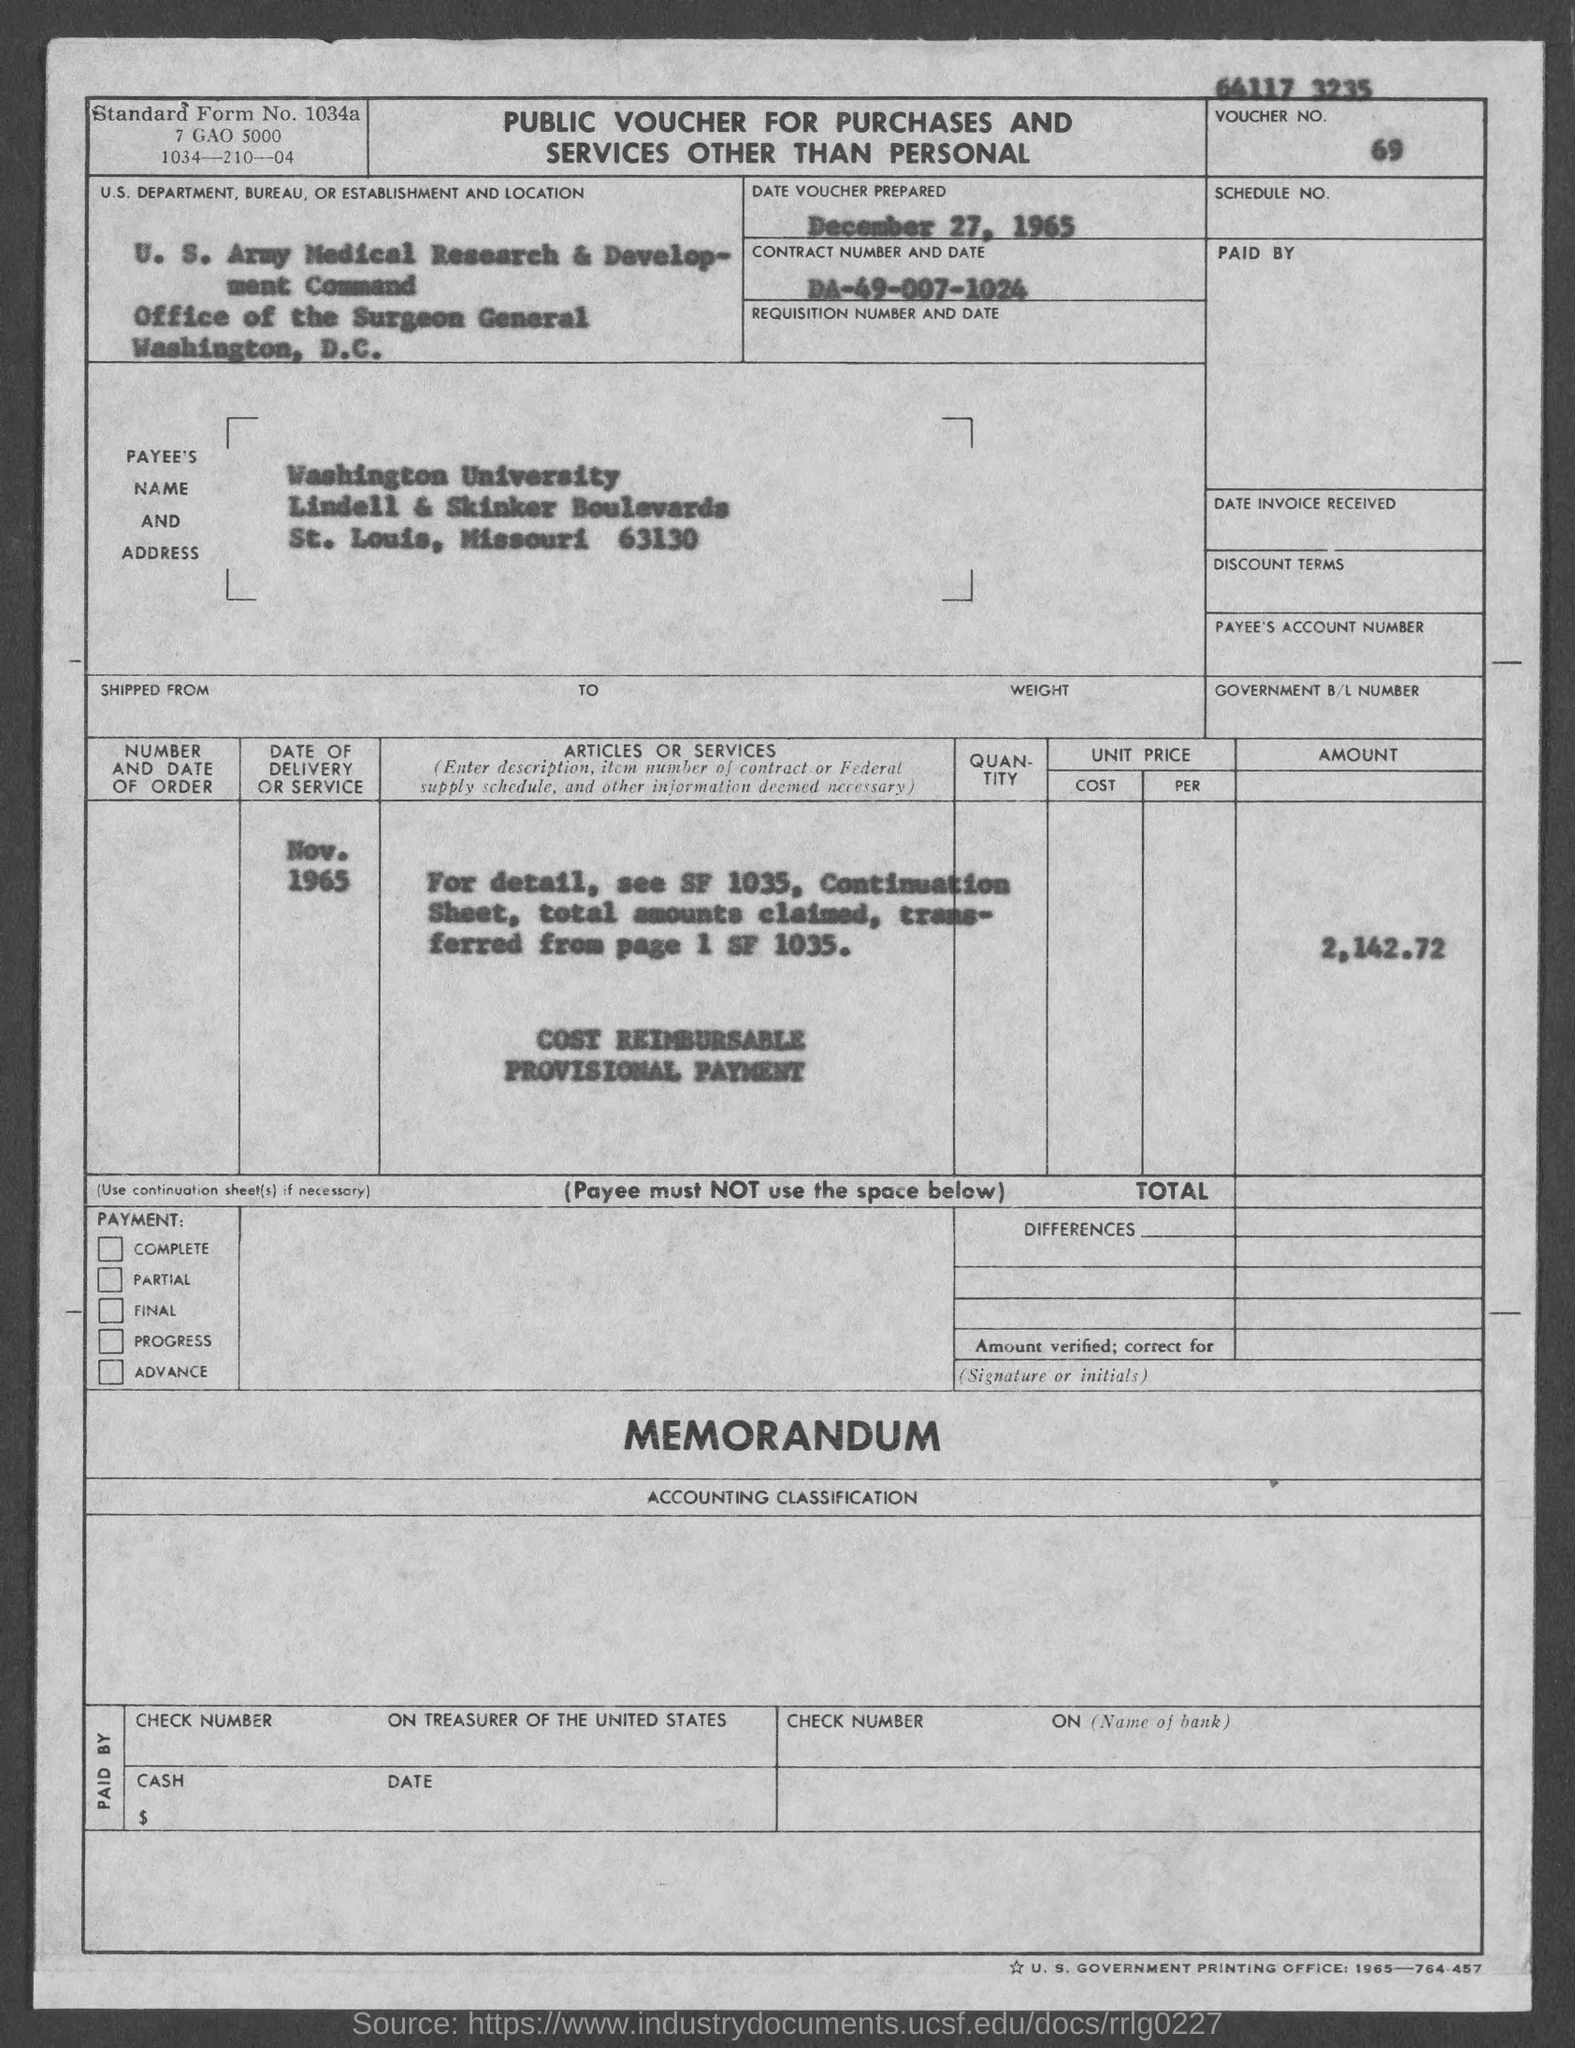What type of voucher is given here?
Ensure brevity in your answer.  Public Voucher for Purchases and Services Other Than Personal. What is the date of voucher prepared?
Your answer should be compact. December 27, 1965. What is the Standard Form No. given in the voucher?
Provide a succinct answer. 1034a. What is the voucher number given in the document?
Your answer should be very brief. 69. What is the Payee name given in the voucher?
Your answer should be very brief. Washington University. What is the total voucher amount given in the document?
Your answer should be very brief. 2,142.72. What is the U.S. Department, Bureau, or Establishment given in the voucher?
Make the answer very short. U. S. Army Medical Research & Development Command. 